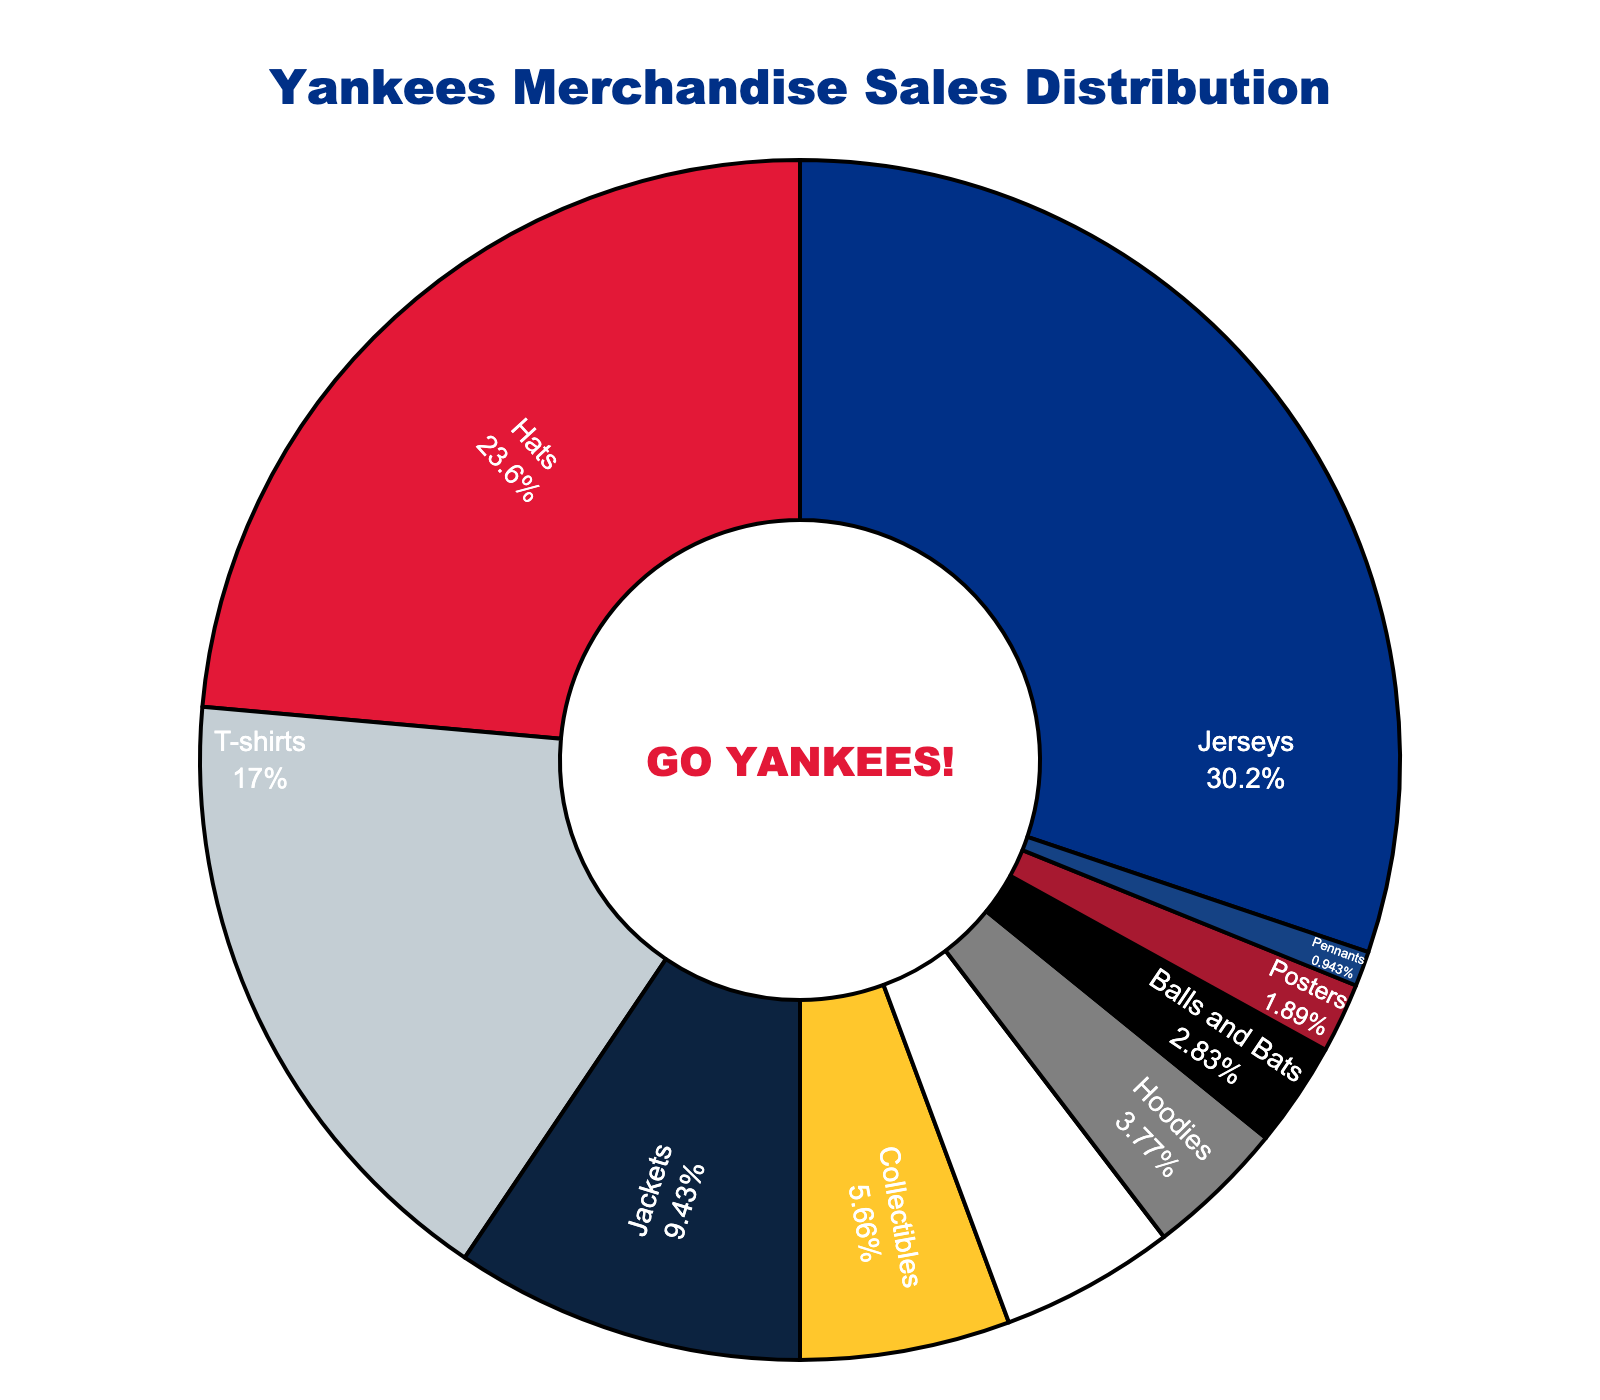Which category represents the largest share of Yankees merchandise sales? The category with the largest pie slice area and label showing the highest percentage value is the largest share
Answer: Jerseys What percentage of Yankees merchandise sales comes from Hats and T-shirts combined? Add the percentages for Hats (25%) and T-shirts (18%). The combined percentage is 25% + 18%
Answer: 43% How do the sales of Jackets compare to Accessories? Jackets have a 10% share of sales, while Accessories have a 5% share. Therefore, Jackets have double the sales of Accessories
Answer: Jackets have double the sales Which categories make up less than 5% of the sales each? Categories with less than a 5% label inside their pie sections are: Hoodies, Balls and Bats, Posters, Pennants
Answer: Hoodies, Balls and Bats, Posters, Pennants What is the combined percentage of Collectibles and Balls and Bats? Collectibles have 6% and Balls and Bats have 3%. Adding them gives 6% + 3% = 9%
Answer: 9% Are the sales from T-shirts greater than the combined sales of Hoodies and Pennants? T-shirts make up 18% of the sales. Hoodies have 4% and Pennants have 1%. The combined sales of Hoodies and Pennants are 4% + 1% = 5%. Thus, 18% > 5%
Answer: Yes What is the smallest category by sales percentage? The smallest pie slice represents the category with "1%" labeled, which is Pennants
Answer: Pennants If Jerseys and Hats together make up 57% of sales, what percentage do the remaining categories account for? Total percentage is 100%, subtract the combined sales of Jerseys (32%) and Hats (25%): 100% - 57% = 43%
Answer: 43% Between Collectibles and Jackets, which category makes up a higher percentage of sales and by how much? Collectibles have a 6% share and Jackets have a 10% share. Jackets lead by 10% - 6% = 4%
Answer: Jackets by 4% How does the visual representation of Accessories differ from Collectibles in terms of color and percentage? Accessories are highlighted in a different color and are shown to occupy a 5% portion of the pie, while Collectibles occupy 6%
Answer: Different color, Collectibles 1% higher 